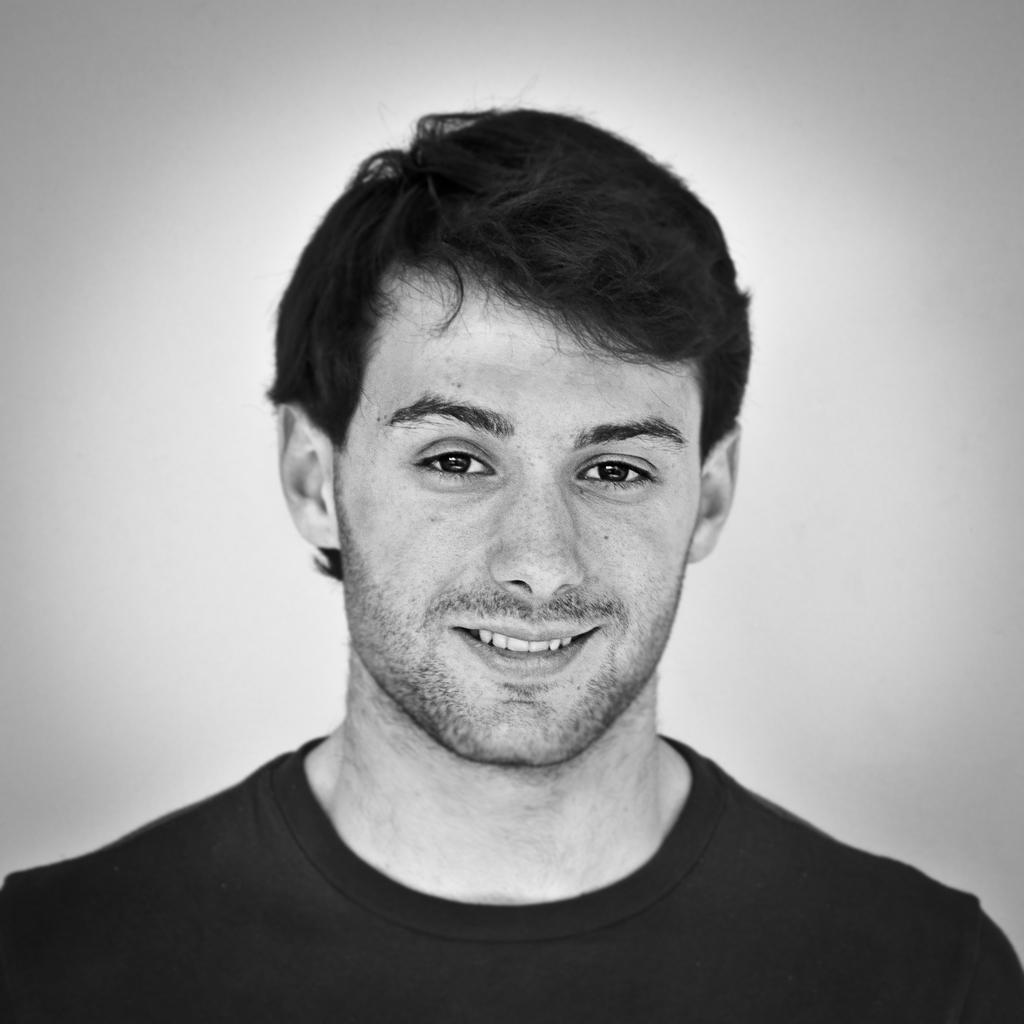What is the main subject of the image? The main subject of the image is a man. What is the man wearing in the image? The man is wearing a black T-shirt in the image. How does the man appear in the image? The man has a smiling face in the image. What is the color of the background in the image? The background of the image is white. What type of soup is the man eating in the image? There is no soup present in the image; the man is wearing a black T-shirt and has a smiling face. 